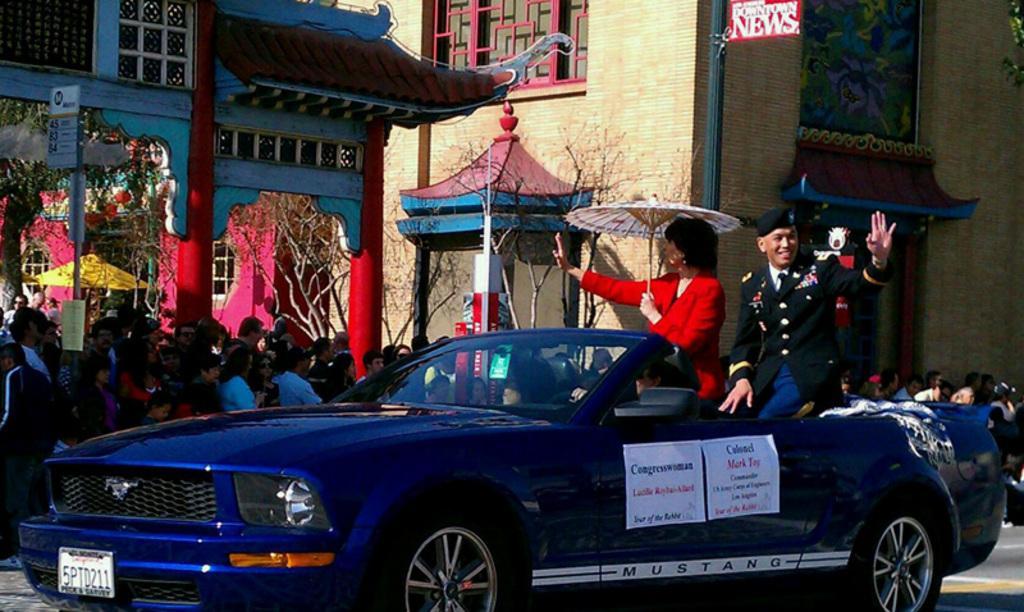Describe this image in one or two sentences. A man in black dress and a woman in red dress, holding an umbrella is sitting on a car. There is a notice in the car. And there is a crowd of people in the side. In the back there is a building. A sign board is there. There are trees in the background. 